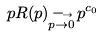<formula> <loc_0><loc_0><loc_500><loc_500>p R ( p ) _ { \stackrel { \longrightarrow } { p \rightarrow 0 } } p ^ { c _ { 0 } }</formula> 